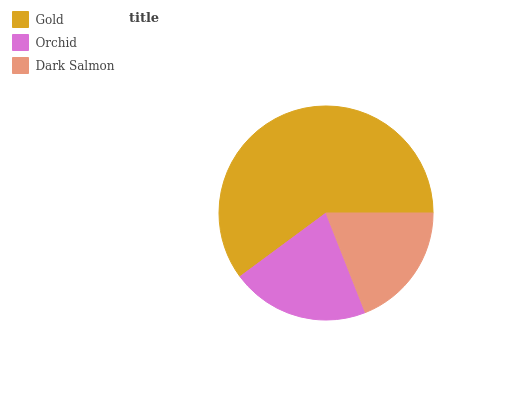Is Dark Salmon the minimum?
Answer yes or no. Yes. Is Gold the maximum?
Answer yes or no. Yes. Is Orchid the minimum?
Answer yes or no. No. Is Orchid the maximum?
Answer yes or no. No. Is Gold greater than Orchid?
Answer yes or no. Yes. Is Orchid less than Gold?
Answer yes or no. Yes. Is Orchid greater than Gold?
Answer yes or no. No. Is Gold less than Orchid?
Answer yes or no. No. Is Orchid the high median?
Answer yes or no. Yes. Is Orchid the low median?
Answer yes or no. Yes. Is Gold the high median?
Answer yes or no. No. Is Dark Salmon the low median?
Answer yes or no. No. 